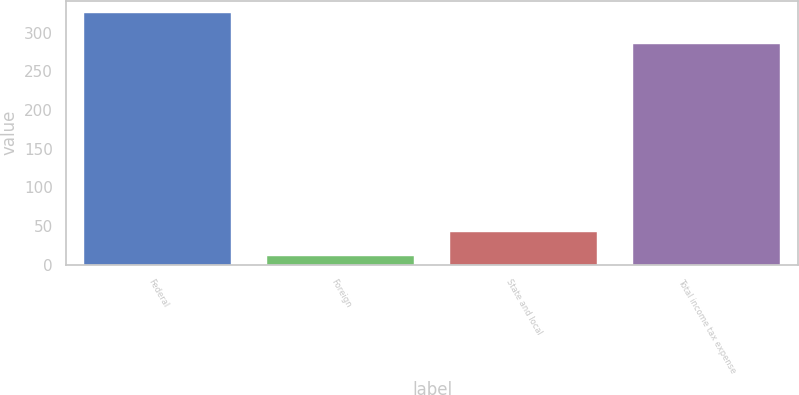Convert chart to OTSL. <chart><loc_0><loc_0><loc_500><loc_500><bar_chart><fcel>Federal<fcel>Foreign<fcel>State and local<fcel>Total income tax expense<nl><fcel>325.1<fcel>11<fcel>42.41<fcel>286.1<nl></chart> 